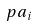Convert formula to latex. <formula><loc_0><loc_0><loc_500><loc_500>p a _ { i }</formula> 